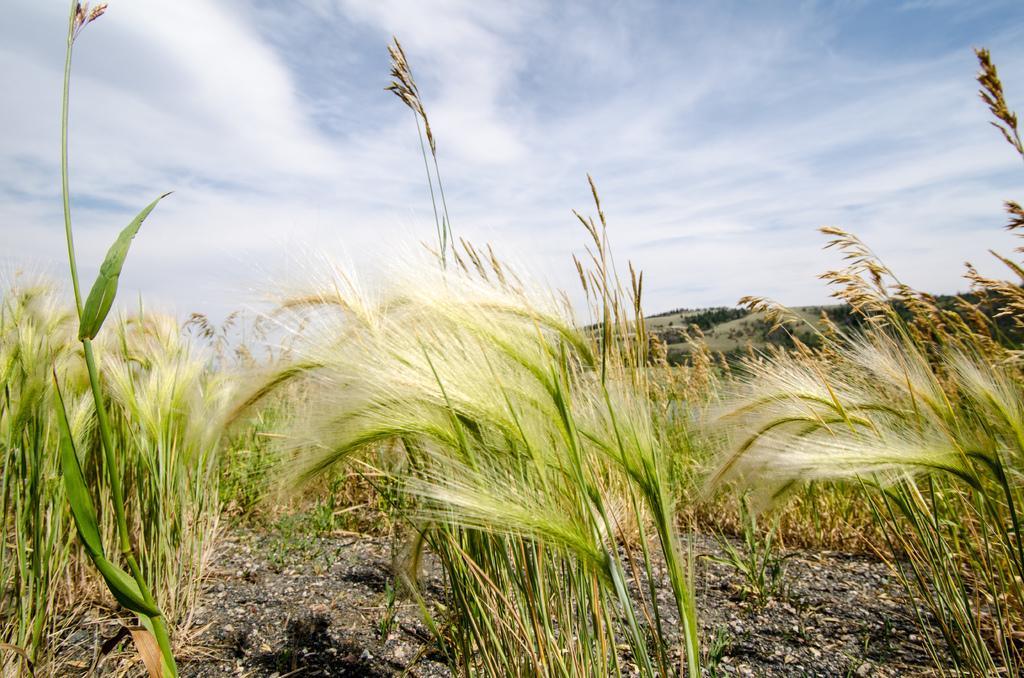In one or two sentences, can you explain what this image depicts? In this image, we can see wheat plants and at the bottom, there is ground. At the top, there is sky. 